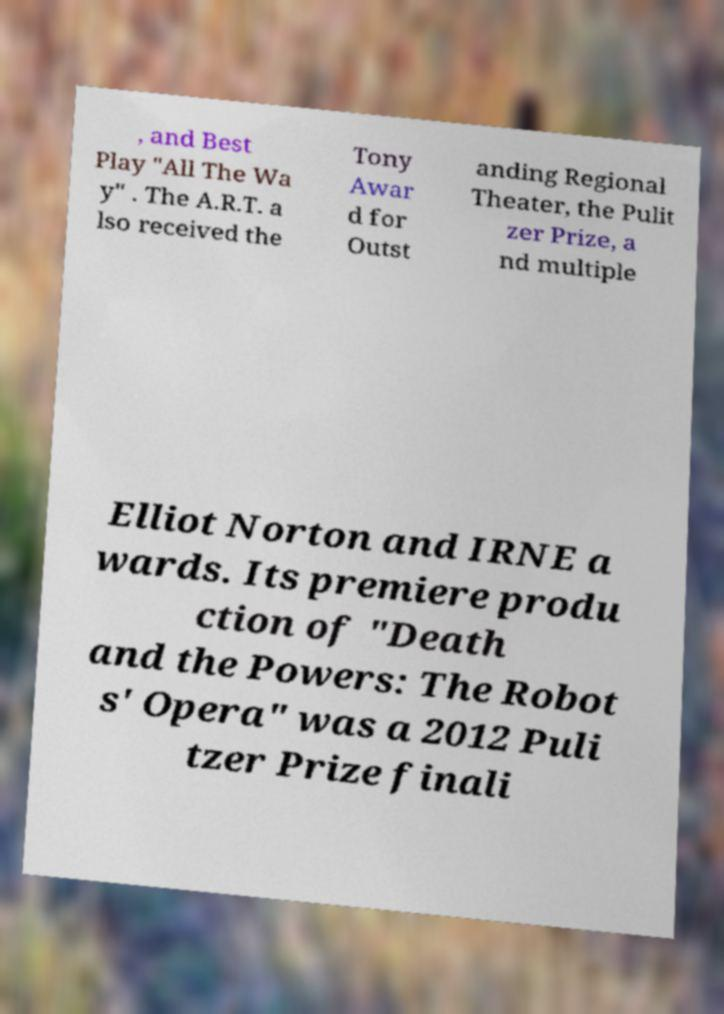I need the written content from this picture converted into text. Can you do that? , and Best Play "All The Wa y" . The A.R.T. a lso received the Tony Awar d for Outst anding Regional Theater, the Pulit zer Prize, a nd multiple Elliot Norton and IRNE a wards. Its premiere produ ction of "Death and the Powers: The Robot s' Opera" was a 2012 Puli tzer Prize finali 